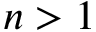Convert formula to latex. <formula><loc_0><loc_0><loc_500><loc_500>n > 1</formula> 